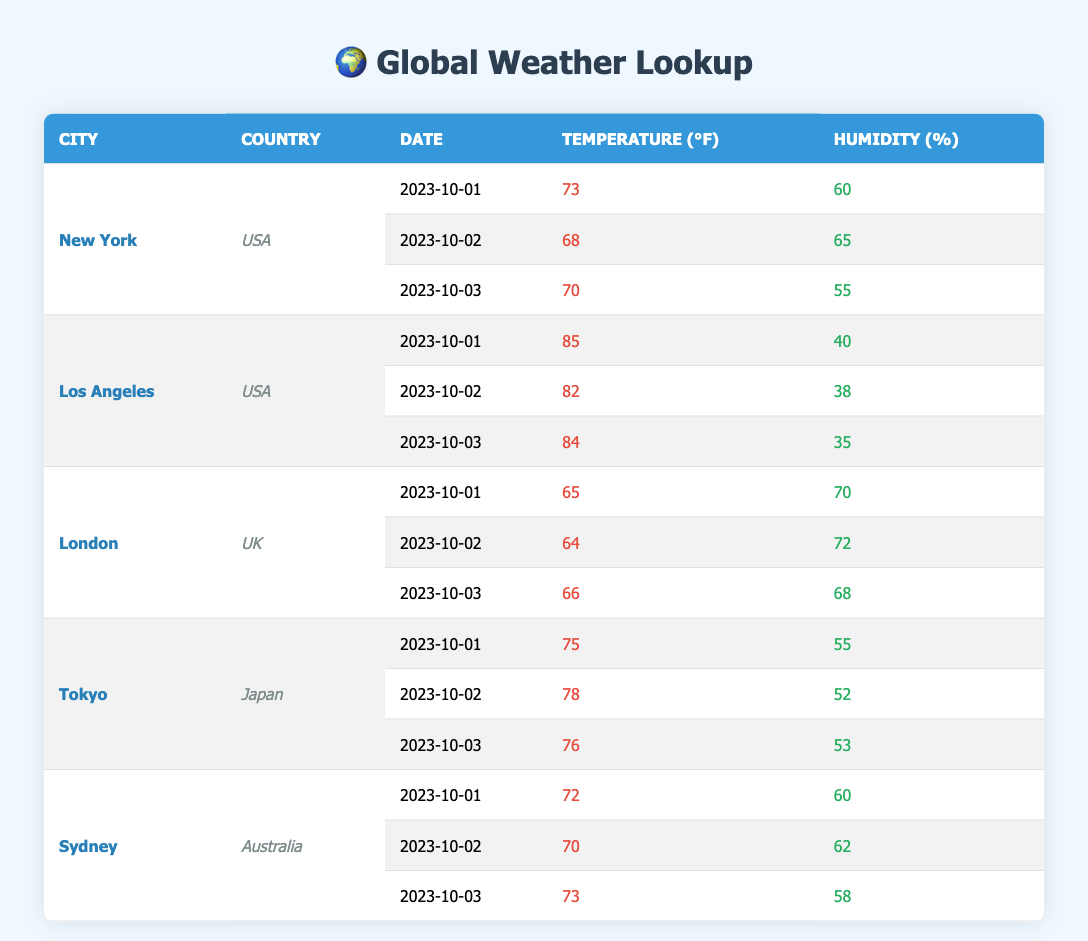What is the highest temperature recorded in New York during the given days? According to the table, the temperatures recorded in New York are 73, 68, and 70 degrees Fahrenheit on the respective dates. The highest among these is 73 degrees on October 1.
Answer: 73 What was the humidity level in Los Angeles on October 3? Looking at the table, the humidity recorded for Los Angeles on October 3 is 35 percent.
Answer: 35 Which city recorded the lowest humidity on October 1? The table shows that on October 1, New York had 60 percent, Los Angeles 40 percent, London 70 percent, Tokyo 55 percent, and Sydney 60 percent humidity. The lowest is from Los Angeles with 40 percent.
Answer: Los Angeles What is the average temperature in Tokyo for the given dates? The temperatures for Tokyo are 75, 78, and 76 degrees Fahrenheit. To find the average, we sum these temperatures (75 + 78 + 76 = 229) and divide by the number of days (3), resulting in an average of 76.33 degrees.
Answer: 76.33 Did London experience a decrease in temperature from October 1 to October 2? The recorded temperatures for London are 65 degrees on October 1 and 64 degrees on October 2. Since 64 is less than 65, there is indeed a decrease.
Answer: Yes Calculate the difference in humidity between Sydney on October 1 and October 3. The humidity for Sydney on October 1 is 60 percent and on October 3 is 58 percent. The difference is calculated as (60 - 58 = 2).
Answer: 2 Which city had the highest average humidity across the three recorded days? The humidities for each city over the three days are: New York (60, 65, 55) - average 60, Los Angeles (40, 38, 35) - average 37.67, London (70, 72, 68) - average 70, Tokyo (55, 52, 53) - average 53.33, Sydney (60, 62, 58) - average 60. The highest average is from London at 70.
Answer: London Was the average temperature in Los Angeles higher than Sydney over the recorded period? The temperatures recorded are: Los Angeles (85, 82, 84) - average 83.67, and Sydney (72, 70, 73) - average 71.67. Since 83.67 is greater than 71.67, Los Angeles had a higher average temperature.
Answer: Yes 